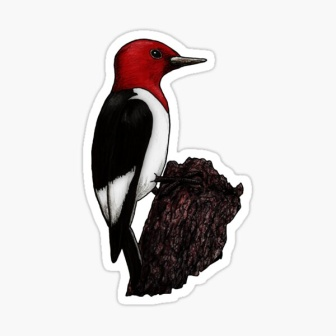Imagine a story set in the world of this image. Describe the woodpecker's day. Once upon a time in a peaceful forest, there lived a red-headed woodpecker named Ruby. Ruby woke up at dawn with the first rays of sunlight filtering through the dense canopy of leaves above. Perched on her favorite tree stump, she began her day with a series of rhythmic pecks on the bark, searching for succulent insects hidden within. The forest was alive with the sounds of chirping birds and rustling leaves. Ruby's vibrant red head and striking plumage made her a prominent figure in the forest community. She flew from tree to tree, her sharp eyes scanning for both food and potential threats. As noon approached, Ruby took a break, basking in a sunlit glade and preening her feathers until they gleamed. The afternoon was spent exploring new parts of the forest, meeting other birds, and calling out with her distinctive laugh-like call. As the sun set, painting the sky in hues of orange and pink, Ruby returned to her tree stump, where she nestled into a nook she had carved out, ready to rest and dream of the adventures that tomorrow would bring. The balance of harmony and natural splendor in the forest was a testament to the beauty of the untouched world that Ruby called home. 